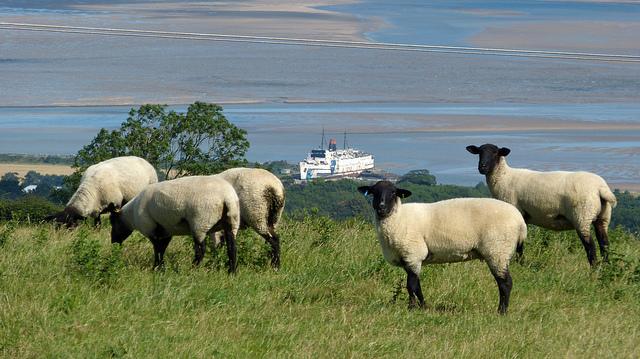What animals are photographed?
Quick response, please. Sheep. What color are the animals faces?
Concise answer only. Black. What number of sheep are standing under the tree?
Give a very brief answer. 0. Is there a boat in the picture?
Answer briefly. Yes. 